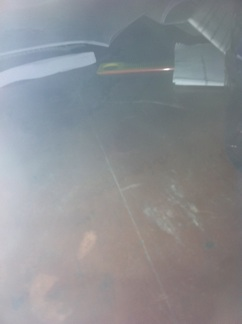How would you describe this image to someone who can't see it? The image shows a dimly lit table with a few items on it, including a book and a pen. The surface of the table seems dusty or smudged, giving it a slightly neglected appearance. The atmosphere is somewhat gloomy and mysterious. 